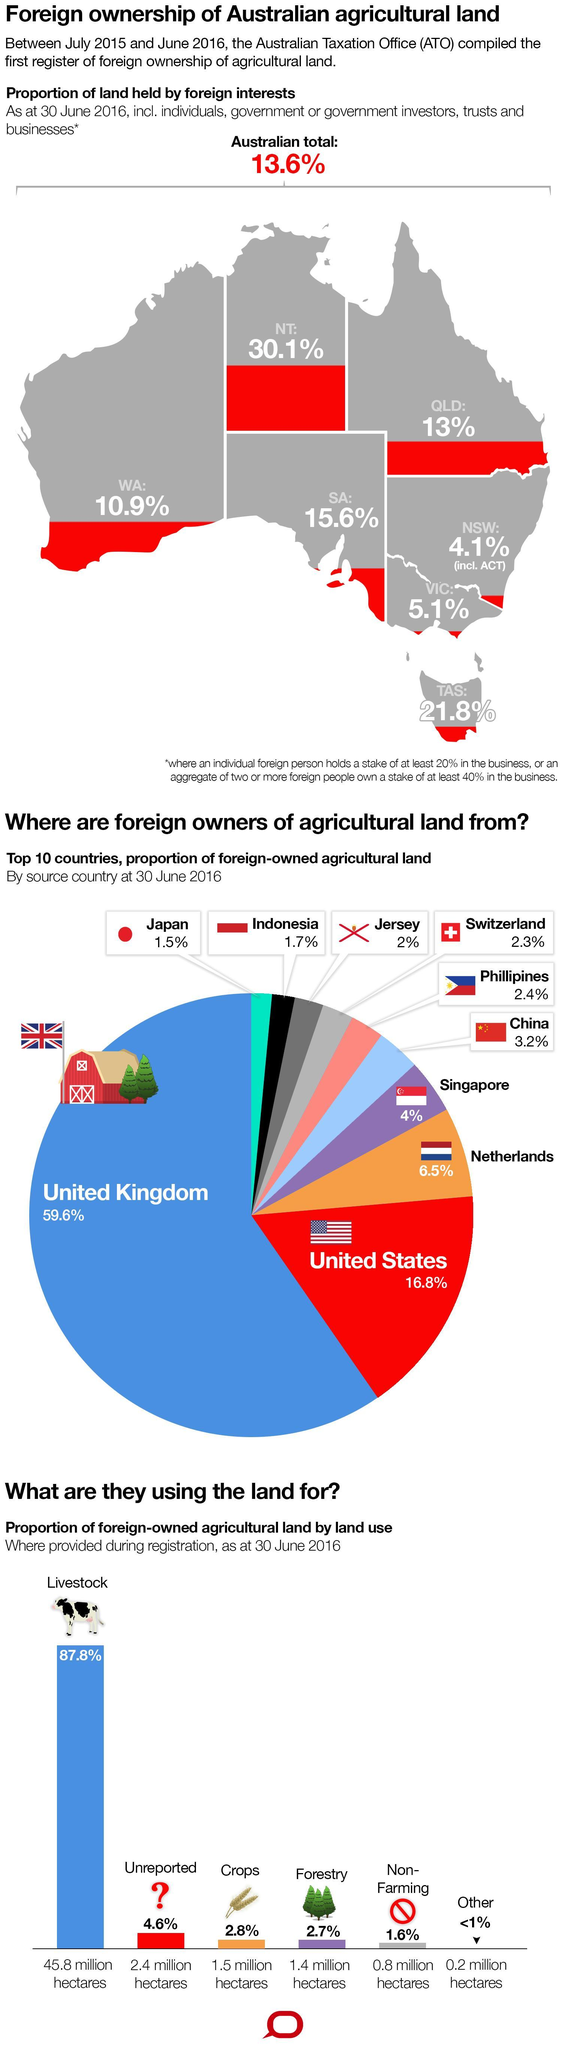What is the percentage of livestock and forestry taken together?
Answer the question with a short phrase. 90.5% What is the percentage of livestock and crops taken together? 90.6% Which country has the second-highest share of agricultural land? United States Which country has the highest share of agricultural land? United Kingdom 